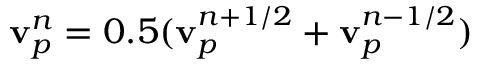<formula> <loc_0><loc_0><loc_500><loc_500>{ v } _ { p } ^ { n } = 0 . 5 ( { v } _ { p } ^ { n + 1 / 2 } + { v } _ { p } ^ { n - 1 / 2 } )</formula> 